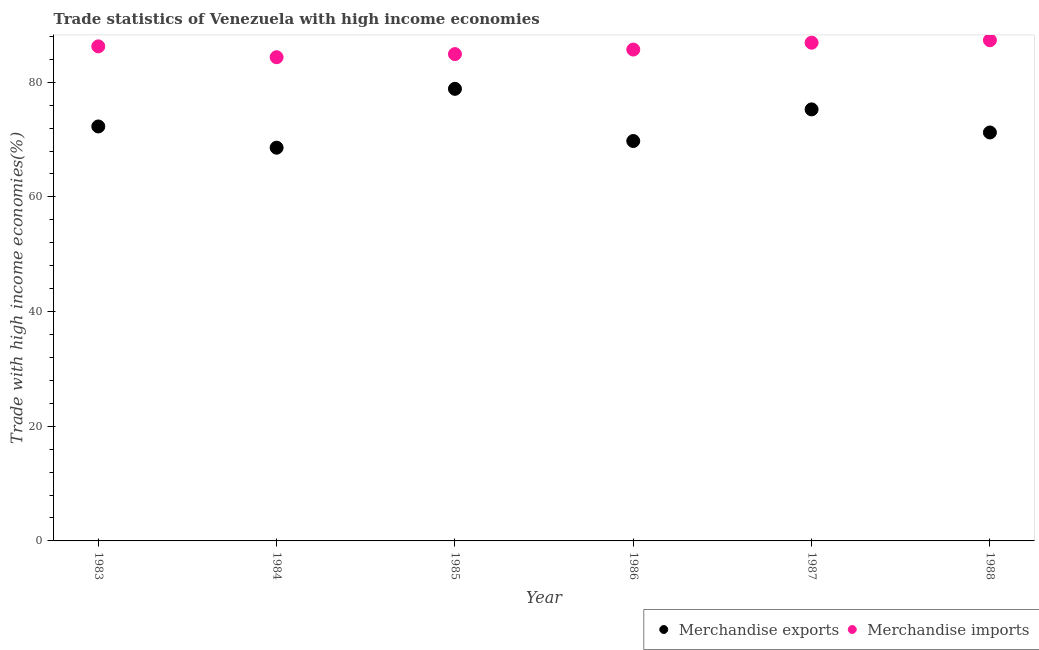How many different coloured dotlines are there?
Offer a terse response. 2. Is the number of dotlines equal to the number of legend labels?
Your answer should be compact. Yes. What is the merchandise exports in 1986?
Offer a terse response. 69.75. Across all years, what is the maximum merchandise imports?
Ensure brevity in your answer.  87.32. Across all years, what is the minimum merchandise imports?
Provide a succinct answer. 84.36. In which year was the merchandise exports maximum?
Your answer should be compact. 1985. What is the total merchandise exports in the graph?
Make the answer very short. 435.94. What is the difference between the merchandise imports in 1985 and that in 1987?
Your answer should be compact. -1.99. What is the difference between the merchandise imports in 1985 and the merchandise exports in 1983?
Make the answer very short. 12.62. What is the average merchandise exports per year?
Your response must be concise. 72.66. In the year 1985, what is the difference between the merchandise imports and merchandise exports?
Provide a short and direct response. 6.06. What is the ratio of the merchandise exports in 1983 to that in 1988?
Offer a very short reply. 1.01. Is the difference between the merchandise imports in 1984 and 1985 greater than the difference between the merchandise exports in 1984 and 1985?
Provide a succinct answer. Yes. What is the difference between the highest and the second highest merchandise imports?
Provide a succinct answer. 0.43. What is the difference between the highest and the lowest merchandise exports?
Ensure brevity in your answer.  10.26. How many dotlines are there?
Keep it short and to the point. 2. What is the difference between two consecutive major ticks on the Y-axis?
Provide a succinct answer. 20. Are the values on the major ticks of Y-axis written in scientific E-notation?
Give a very brief answer. No. Does the graph contain grids?
Make the answer very short. No. Where does the legend appear in the graph?
Make the answer very short. Bottom right. How many legend labels are there?
Make the answer very short. 2. How are the legend labels stacked?
Your response must be concise. Horizontal. What is the title of the graph?
Your answer should be compact. Trade statistics of Venezuela with high income economies. Does "DAC donors" appear as one of the legend labels in the graph?
Your answer should be very brief. No. What is the label or title of the Y-axis?
Keep it short and to the point. Trade with high income economies(%). What is the Trade with high income economies(%) in Merchandise exports in 1983?
Offer a very short reply. 72.28. What is the Trade with high income economies(%) in Merchandise imports in 1983?
Your response must be concise. 86.25. What is the Trade with high income economies(%) of Merchandise exports in 1984?
Your answer should be very brief. 68.58. What is the Trade with high income economies(%) of Merchandise imports in 1984?
Offer a very short reply. 84.36. What is the Trade with high income economies(%) of Merchandise exports in 1985?
Your answer should be very brief. 78.84. What is the Trade with high income economies(%) in Merchandise imports in 1985?
Your answer should be compact. 84.9. What is the Trade with high income economies(%) of Merchandise exports in 1986?
Provide a succinct answer. 69.75. What is the Trade with high income economies(%) of Merchandise imports in 1986?
Your answer should be compact. 85.69. What is the Trade with high income economies(%) in Merchandise exports in 1987?
Make the answer very short. 75.26. What is the Trade with high income economies(%) of Merchandise imports in 1987?
Give a very brief answer. 86.89. What is the Trade with high income economies(%) in Merchandise exports in 1988?
Offer a very short reply. 71.23. What is the Trade with high income economies(%) of Merchandise imports in 1988?
Offer a terse response. 87.32. Across all years, what is the maximum Trade with high income economies(%) in Merchandise exports?
Your answer should be very brief. 78.84. Across all years, what is the maximum Trade with high income economies(%) in Merchandise imports?
Your answer should be compact. 87.32. Across all years, what is the minimum Trade with high income economies(%) in Merchandise exports?
Provide a short and direct response. 68.58. Across all years, what is the minimum Trade with high income economies(%) in Merchandise imports?
Offer a terse response. 84.36. What is the total Trade with high income economies(%) in Merchandise exports in the graph?
Provide a short and direct response. 435.94. What is the total Trade with high income economies(%) of Merchandise imports in the graph?
Offer a very short reply. 515.41. What is the difference between the Trade with high income economies(%) in Merchandise exports in 1983 and that in 1984?
Your answer should be compact. 3.7. What is the difference between the Trade with high income economies(%) of Merchandise imports in 1983 and that in 1984?
Ensure brevity in your answer.  1.89. What is the difference between the Trade with high income economies(%) of Merchandise exports in 1983 and that in 1985?
Your answer should be very brief. -6.56. What is the difference between the Trade with high income economies(%) of Merchandise imports in 1983 and that in 1985?
Provide a short and direct response. 1.35. What is the difference between the Trade with high income economies(%) of Merchandise exports in 1983 and that in 1986?
Your answer should be very brief. 2.54. What is the difference between the Trade with high income economies(%) in Merchandise imports in 1983 and that in 1986?
Your answer should be very brief. 0.56. What is the difference between the Trade with high income economies(%) of Merchandise exports in 1983 and that in 1987?
Your answer should be compact. -2.98. What is the difference between the Trade with high income economies(%) in Merchandise imports in 1983 and that in 1987?
Offer a terse response. -0.64. What is the difference between the Trade with high income economies(%) in Merchandise exports in 1983 and that in 1988?
Provide a short and direct response. 1.05. What is the difference between the Trade with high income economies(%) of Merchandise imports in 1983 and that in 1988?
Make the answer very short. -1.07. What is the difference between the Trade with high income economies(%) in Merchandise exports in 1984 and that in 1985?
Your response must be concise. -10.26. What is the difference between the Trade with high income economies(%) of Merchandise imports in 1984 and that in 1985?
Give a very brief answer. -0.54. What is the difference between the Trade with high income economies(%) of Merchandise exports in 1984 and that in 1986?
Your response must be concise. -1.17. What is the difference between the Trade with high income economies(%) of Merchandise imports in 1984 and that in 1986?
Offer a terse response. -1.33. What is the difference between the Trade with high income economies(%) of Merchandise exports in 1984 and that in 1987?
Ensure brevity in your answer.  -6.68. What is the difference between the Trade with high income economies(%) in Merchandise imports in 1984 and that in 1987?
Make the answer very short. -2.53. What is the difference between the Trade with high income economies(%) of Merchandise exports in 1984 and that in 1988?
Offer a very short reply. -2.65. What is the difference between the Trade with high income economies(%) of Merchandise imports in 1984 and that in 1988?
Your response must be concise. -2.96. What is the difference between the Trade with high income economies(%) of Merchandise exports in 1985 and that in 1986?
Your answer should be compact. 9.1. What is the difference between the Trade with high income economies(%) of Merchandise imports in 1985 and that in 1986?
Provide a short and direct response. -0.79. What is the difference between the Trade with high income economies(%) in Merchandise exports in 1985 and that in 1987?
Provide a succinct answer. 3.58. What is the difference between the Trade with high income economies(%) in Merchandise imports in 1985 and that in 1987?
Your response must be concise. -1.99. What is the difference between the Trade with high income economies(%) in Merchandise exports in 1985 and that in 1988?
Your answer should be very brief. 7.61. What is the difference between the Trade with high income economies(%) of Merchandise imports in 1985 and that in 1988?
Make the answer very short. -2.42. What is the difference between the Trade with high income economies(%) in Merchandise exports in 1986 and that in 1987?
Make the answer very short. -5.52. What is the difference between the Trade with high income economies(%) of Merchandise imports in 1986 and that in 1987?
Your answer should be compact. -1.2. What is the difference between the Trade with high income economies(%) of Merchandise exports in 1986 and that in 1988?
Give a very brief answer. -1.49. What is the difference between the Trade with high income economies(%) of Merchandise imports in 1986 and that in 1988?
Offer a very short reply. -1.62. What is the difference between the Trade with high income economies(%) of Merchandise exports in 1987 and that in 1988?
Provide a short and direct response. 4.03. What is the difference between the Trade with high income economies(%) in Merchandise imports in 1987 and that in 1988?
Ensure brevity in your answer.  -0.43. What is the difference between the Trade with high income economies(%) of Merchandise exports in 1983 and the Trade with high income economies(%) of Merchandise imports in 1984?
Provide a short and direct response. -12.08. What is the difference between the Trade with high income economies(%) of Merchandise exports in 1983 and the Trade with high income economies(%) of Merchandise imports in 1985?
Keep it short and to the point. -12.62. What is the difference between the Trade with high income economies(%) in Merchandise exports in 1983 and the Trade with high income economies(%) in Merchandise imports in 1986?
Keep it short and to the point. -13.41. What is the difference between the Trade with high income economies(%) of Merchandise exports in 1983 and the Trade with high income economies(%) of Merchandise imports in 1987?
Offer a very short reply. -14.61. What is the difference between the Trade with high income economies(%) in Merchandise exports in 1983 and the Trade with high income economies(%) in Merchandise imports in 1988?
Make the answer very short. -15.04. What is the difference between the Trade with high income economies(%) in Merchandise exports in 1984 and the Trade with high income economies(%) in Merchandise imports in 1985?
Your answer should be very brief. -16.32. What is the difference between the Trade with high income economies(%) of Merchandise exports in 1984 and the Trade with high income economies(%) of Merchandise imports in 1986?
Provide a succinct answer. -17.11. What is the difference between the Trade with high income economies(%) of Merchandise exports in 1984 and the Trade with high income economies(%) of Merchandise imports in 1987?
Offer a terse response. -18.31. What is the difference between the Trade with high income economies(%) of Merchandise exports in 1984 and the Trade with high income economies(%) of Merchandise imports in 1988?
Keep it short and to the point. -18.74. What is the difference between the Trade with high income economies(%) of Merchandise exports in 1985 and the Trade with high income economies(%) of Merchandise imports in 1986?
Your answer should be very brief. -6.85. What is the difference between the Trade with high income economies(%) in Merchandise exports in 1985 and the Trade with high income economies(%) in Merchandise imports in 1987?
Your answer should be very brief. -8.05. What is the difference between the Trade with high income economies(%) in Merchandise exports in 1985 and the Trade with high income economies(%) in Merchandise imports in 1988?
Give a very brief answer. -8.47. What is the difference between the Trade with high income economies(%) in Merchandise exports in 1986 and the Trade with high income economies(%) in Merchandise imports in 1987?
Offer a terse response. -17.14. What is the difference between the Trade with high income economies(%) in Merchandise exports in 1986 and the Trade with high income economies(%) in Merchandise imports in 1988?
Your answer should be very brief. -17.57. What is the difference between the Trade with high income economies(%) in Merchandise exports in 1987 and the Trade with high income economies(%) in Merchandise imports in 1988?
Give a very brief answer. -12.06. What is the average Trade with high income economies(%) of Merchandise exports per year?
Provide a succinct answer. 72.66. What is the average Trade with high income economies(%) of Merchandise imports per year?
Provide a short and direct response. 85.9. In the year 1983, what is the difference between the Trade with high income economies(%) of Merchandise exports and Trade with high income economies(%) of Merchandise imports?
Offer a very short reply. -13.97. In the year 1984, what is the difference between the Trade with high income economies(%) in Merchandise exports and Trade with high income economies(%) in Merchandise imports?
Provide a succinct answer. -15.78. In the year 1985, what is the difference between the Trade with high income economies(%) of Merchandise exports and Trade with high income economies(%) of Merchandise imports?
Ensure brevity in your answer.  -6.06. In the year 1986, what is the difference between the Trade with high income economies(%) of Merchandise exports and Trade with high income economies(%) of Merchandise imports?
Provide a succinct answer. -15.95. In the year 1987, what is the difference between the Trade with high income economies(%) of Merchandise exports and Trade with high income economies(%) of Merchandise imports?
Give a very brief answer. -11.63. In the year 1988, what is the difference between the Trade with high income economies(%) of Merchandise exports and Trade with high income economies(%) of Merchandise imports?
Make the answer very short. -16.09. What is the ratio of the Trade with high income economies(%) in Merchandise exports in 1983 to that in 1984?
Your response must be concise. 1.05. What is the ratio of the Trade with high income economies(%) in Merchandise imports in 1983 to that in 1984?
Keep it short and to the point. 1.02. What is the ratio of the Trade with high income economies(%) of Merchandise exports in 1983 to that in 1985?
Provide a succinct answer. 0.92. What is the ratio of the Trade with high income economies(%) in Merchandise imports in 1983 to that in 1985?
Give a very brief answer. 1.02. What is the ratio of the Trade with high income economies(%) of Merchandise exports in 1983 to that in 1986?
Keep it short and to the point. 1.04. What is the ratio of the Trade with high income economies(%) in Merchandise exports in 1983 to that in 1987?
Your answer should be very brief. 0.96. What is the ratio of the Trade with high income economies(%) in Merchandise exports in 1983 to that in 1988?
Keep it short and to the point. 1.01. What is the ratio of the Trade with high income economies(%) of Merchandise exports in 1984 to that in 1985?
Provide a succinct answer. 0.87. What is the ratio of the Trade with high income economies(%) in Merchandise imports in 1984 to that in 1985?
Keep it short and to the point. 0.99. What is the ratio of the Trade with high income economies(%) of Merchandise exports in 1984 to that in 1986?
Your response must be concise. 0.98. What is the ratio of the Trade with high income economies(%) of Merchandise imports in 1984 to that in 1986?
Ensure brevity in your answer.  0.98. What is the ratio of the Trade with high income economies(%) of Merchandise exports in 1984 to that in 1987?
Your answer should be very brief. 0.91. What is the ratio of the Trade with high income economies(%) in Merchandise imports in 1984 to that in 1987?
Keep it short and to the point. 0.97. What is the ratio of the Trade with high income economies(%) of Merchandise exports in 1984 to that in 1988?
Provide a short and direct response. 0.96. What is the ratio of the Trade with high income economies(%) in Merchandise imports in 1984 to that in 1988?
Your response must be concise. 0.97. What is the ratio of the Trade with high income economies(%) of Merchandise exports in 1985 to that in 1986?
Provide a succinct answer. 1.13. What is the ratio of the Trade with high income economies(%) of Merchandise imports in 1985 to that in 1986?
Provide a succinct answer. 0.99. What is the ratio of the Trade with high income economies(%) of Merchandise exports in 1985 to that in 1987?
Provide a short and direct response. 1.05. What is the ratio of the Trade with high income economies(%) in Merchandise imports in 1985 to that in 1987?
Offer a terse response. 0.98. What is the ratio of the Trade with high income economies(%) of Merchandise exports in 1985 to that in 1988?
Provide a short and direct response. 1.11. What is the ratio of the Trade with high income economies(%) in Merchandise imports in 1985 to that in 1988?
Make the answer very short. 0.97. What is the ratio of the Trade with high income economies(%) in Merchandise exports in 1986 to that in 1987?
Your answer should be compact. 0.93. What is the ratio of the Trade with high income economies(%) of Merchandise imports in 1986 to that in 1987?
Your answer should be compact. 0.99. What is the ratio of the Trade with high income economies(%) in Merchandise exports in 1986 to that in 1988?
Your response must be concise. 0.98. What is the ratio of the Trade with high income economies(%) of Merchandise imports in 1986 to that in 1988?
Offer a very short reply. 0.98. What is the ratio of the Trade with high income economies(%) in Merchandise exports in 1987 to that in 1988?
Your answer should be compact. 1.06. What is the ratio of the Trade with high income economies(%) of Merchandise imports in 1987 to that in 1988?
Your answer should be compact. 1. What is the difference between the highest and the second highest Trade with high income economies(%) of Merchandise exports?
Provide a succinct answer. 3.58. What is the difference between the highest and the second highest Trade with high income economies(%) in Merchandise imports?
Give a very brief answer. 0.43. What is the difference between the highest and the lowest Trade with high income economies(%) in Merchandise exports?
Your answer should be compact. 10.26. What is the difference between the highest and the lowest Trade with high income economies(%) in Merchandise imports?
Your response must be concise. 2.96. 